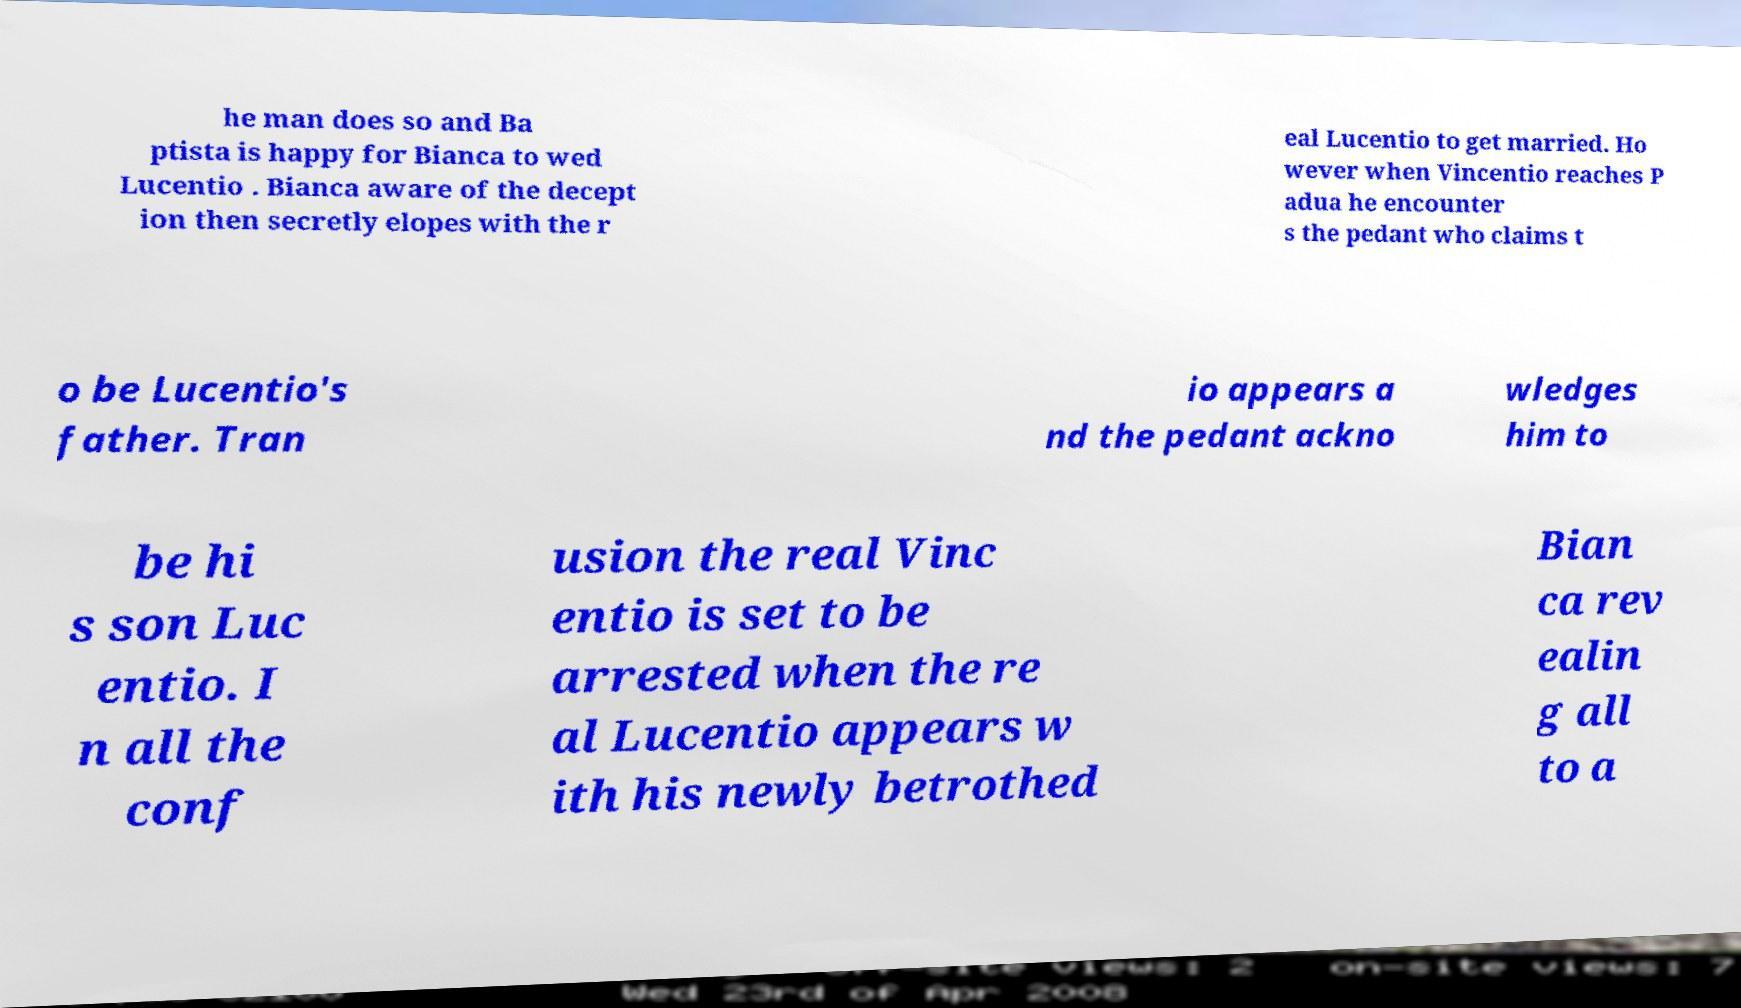Please identify and transcribe the text found in this image. he man does so and Ba ptista is happy for Bianca to wed Lucentio . Bianca aware of the decept ion then secretly elopes with the r eal Lucentio to get married. Ho wever when Vincentio reaches P adua he encounter s the pedant who claims t o be Lucentio's father. Tran io appears a nd the pedant ackno wledges him to be hi s son Luc entio. I n all the conf usion the real Vinc entio is set to be arrested when the re al Lucentio appears w ith his newly betrothed Bian ca rev ealin g all to a 